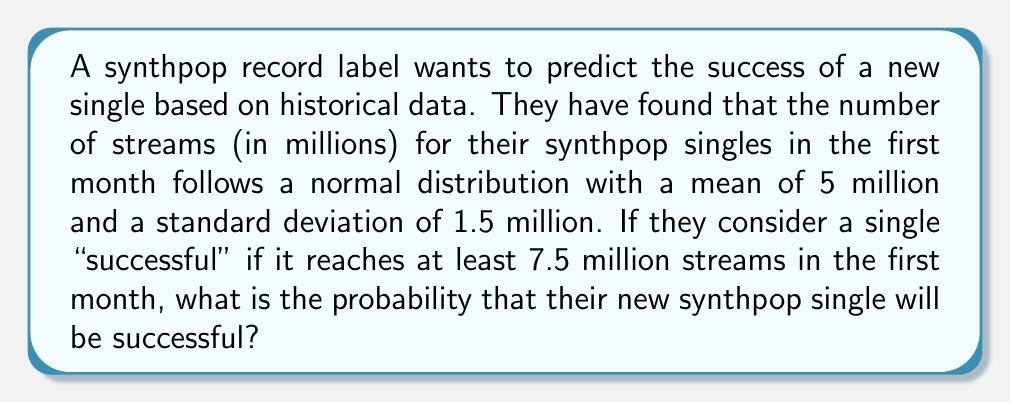Help me with this question. To solve this problem, we need to use the properties of the normal distribution and calculate the z-score for the given threshold.

Given:
- The number of streams follows a normal distribution
- Mean (μ) = 5 million streams
- Standard deviation (σ) = 1.5 million streams
- Success threshold = 7.5 million streams

Step 1: Calculate the z-score for the success threshold.
The z-score formula is:
$$ z = \frac{x - \mu}{\sigma} $$

Where:
x = success threshold
μ = mean
σ = standard deviation

Plugging in the values:
$$ z = \frac{7.5 - 5}{1.5} = \frac{2.5}{1.5} \approx 1.67 $$

Step 2: Use a standard normal distribution table or calculator to find the area to the right of the z-score.

The area to the right of z = 1.67 represents the probability of a single being successful.

Using a standard normal distribution table or calculator, we find:
P(Z > 1.67) ≈ 0.0475

Step 3: Convert the probability to a percentage.
0.0475 × 100% = 4.75%

Therefore, the probability that the new synthpop single will be successful (reach at least 7.5 million streams in the first month) is approximately 4.75%.
Answer: 4.75% 